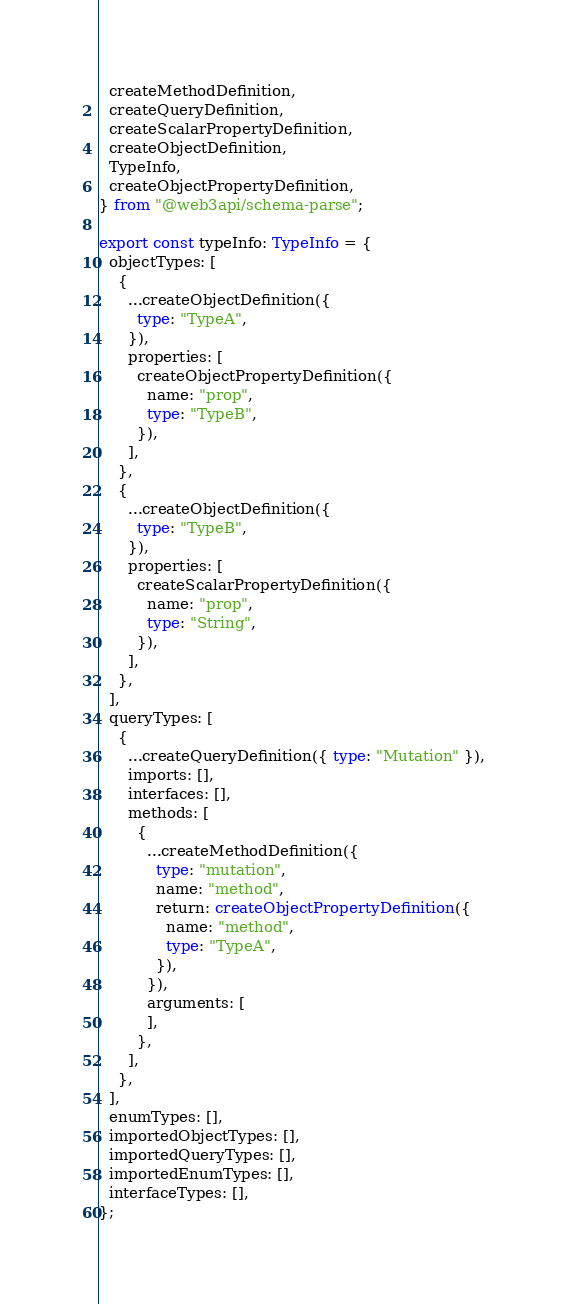Convert code to text. <code><loc_0><loc_0><loc_500><loc_500><_TypeScript_>  createMethodDefinition,
  createQueryDefinition,
  createScalarPropertyDefinition,
  createObjectDefinition,
  TypeInfo,
  createObjectPropertyDefinition,
} from "@web3api/schema-parse";

export const typeInfo: TypeInfo = {
  objectTypes: [
    {
      ...createObjectDefinition({
        type: "TypeA",
      }),
      properties: [
        createObjectPropertyDefinition({
          name: "prop",
          type: "TypeB",
        }),
      ],
    },
    {
      ...createObjectDefinition({
        type: "TypeB",
      }),
      properties: [
        createScalarPropertyDefinition({
          name: "prop",
          type: "String",
        }),
      ],
    },
  ],
  queryTypes: [
    {
      ...createQueryDefinition({ type: "Mutation" }),
      imports: [],
      interfaces: [],
      methods: [
        {
          ...createMethodDefinition({
            type: "mutation",
            name: "method",
            return: createObjectPropertyDefinition({
              name: "method",
              type: "TypeA",
            }),
          }),
          arguments: [
          ],
        },
      ],
    },
  ],
  enumTypes: [],
  importedObjectTypes: [],
  importedQueryTypes: [],
  importedEnumTypes: [],
  interfaceTypes: [],
};
</code> 